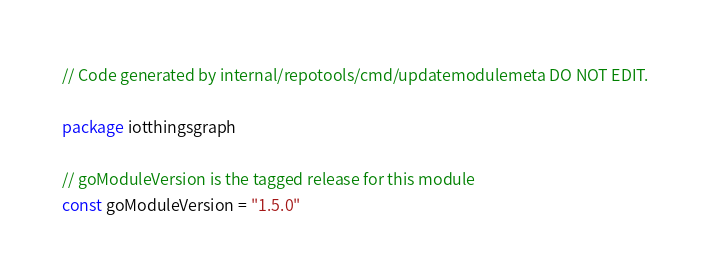<code> <loc_0><loc_0><loc_500><loc_500><_Go_>// Code generated by internal/repotools/cmd/updatemodulemeta DO NOT EDIT.

package iotthingsgraph

// goModuleVersion is the tagged release for this module
const goModuleVersion = "1.5.0"
</code> 